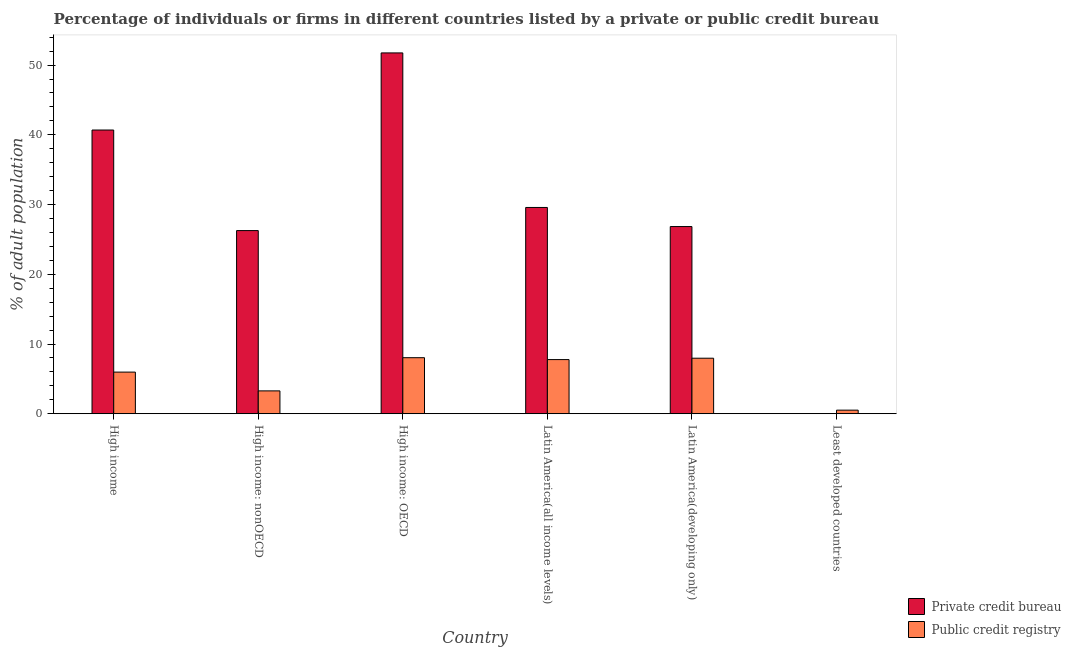How many groups of bars are there?
Provide a short and direct response. 6. Are the number of bars on each tick of the X-axis equal?
Make the answer very short. Yes. How many bars are there on the 5th tick from the right?
Provide a succinct answer. 2. What is the label of the 2nd group of bars from the left?
Provide a succinct answer. High income: nonOECD. In how many cases, is the number of bars for a given country not equal to the number of legend labels?
Your answer should be compact. 0. What is the percentage of firms listed by public credit bureau in Latin America(developing only)?
Your answer should be compact. 7.96. Across all countries, what is the maximum percentage of firms listed by public credit bureau?
Your response must be concise. 8.04. Across all countries, what is the minimum percentage of firms listed by public credit bureau?
Give a very brief answer. 0.51. In which country was the percentage of firms listed by public credit bureau maximum?
Provide a short and direct response. High income: OECD. In which country was the percentage of firms listed by public credit bureau minimum?
Provide a succinct answer. Least developed countries. What is the total percentage of firms listed by private credit bureau in the graph?
Your answer should be compact. 175.12. What is the difference between the percentage of firms listed by public credit bureau in High income and that in High income: OECD?
Your answer should be very brief. -2.06. What is the difference between the percentage of firms listed by private credit bureau in High income: OECD and the percentage of firms listed by public credit bureau in High income?
Your answer should be compact. 45.77. What is the average percentage of firms listed by public credit bureau per country?
Provide a succinct answer. 5.59. What is the difference between the percentage of firms listed by private credit bureau and percentage of firms listed by public credit bureau in High income: nonOECD?
Provide a short and direct response. 22.99. In how many countries, is the percentage of firms listed by private credit bureau greater than 10 %?
Provide a succinct answer. 5. What is the ratio of the percentage of firms listed by private credit bureau in Latin America(all income levels) to that in Latin America(developing only)?
Offer a very short reply. 1.1. Is the percentage of firms listed by public credit bureau in Latin America(developing only) less than that in Least developed countries?
Your answer should be very brief. No. What is the difference between the highest and the second highest percentage of firms listed by private credit bureau?
Give a very brief answer. 11.06. What is the difference between the highest and the lowest percentage of firms listed by public credit bureau?
Provide a short and direct response. 7.52. Is the sum of the percentage of firms listed by private credit bureau in High income: OECD and Latin America(developing only) greater than the maximum percentage of firms listed by public credit bureau across all countries?
Offer a very short reply. Yes. What does the 1st bar from the left in High income: nonOECD represents?
Offer a very short reply. Private credit bureau. What does the 2nd bar from the right in Latin America(developing only) represents?
Your response must be concise. Private credit bureau. Are all the bars in the graph horizontal?
Your answer should be very brief. No. What is the difference between two consecutive major ticks on the Y-axis?
Provide a succinct answer. 10. Does the graph contain any zero values?
Provide a succinct answer. No. How are the legend labels stacked?
Make the answer very short. Vertical. What is the title of the graph?
Offer a terse response. Percentage of individuals or firms in different countries listed by a private or public credit bureau. Does "Manufacturing industries and construction" appear as one of the legend labels in the graph?
Give a very brief answer. No. What is the label or title of the Y-axis?
Provide a short and direct response. % of adult population. What is the % of adult population of Private credit bureau in High income?
Your answer should be compact. 40.69. What is the % of adult population in Public credit registry in High income?
Offer a terse response. 5.97. What is the % of adult population of Private credit bureau in High income: nonOECD?
Your answer should be very brief. 26.27. What is the % of adult population in Public credit registry in High income: nonOECD?
Your response must be concise. 3.28. What is the % of adult population in Private credit bureau in High income: OECD?
Make the answer very short. 51.74. What is the % of adult population in Public credit registry in High income: OECD?
Give a very brief answer. 8.04. What is the % of adult population of Private credit bureau in Latin America(all income levels)?
Ensure brevity in your answer.  29.58. What is the % of adult population in Public credit registry in Latin America(all income levels)?
Provide a succinct answer. 7.77. What is the % of adult population of Private credit bureau in Latin America(developing only)?
Provide a succinct answer. 26.84. What is the % of adult population in Public credit registry in Latin America(developing only)?
Give a very brief answer. 7.96. What is the % of adult population in Private credit bureau in Least developed countries?
Your answer should be compact. 0. What is the % of adult population of Public credit registry in Least developed countries?
Keep it short and to the point. 0.51. Across all countries, what is the maximum % of adult population in Private credit bureau?
Keep it short and to the point. 51.74. Across all countries, what is the maximum % of adult population of Public credit registry?
Ensure brevity in your answer.  8.04. Across all countries, what is the minimum % of adult population in Private credit bureau?
Your answer should be very brief. 0. Across all countries, what is the minimum % of adult population of Public credit registry?
Provide a succinct answer. 0.51. What is the total % of adult population in Private credit bureau in the graph?
Your response must be concise. 175.12. What is the total % of adult population in Public credit registry in the graph?
Your response must be concise. 33.53. What is the difference between the % of adult population in Private credit bureau in High income and that in High income: nonOECD?
Your answer should be very brief. 14.42. What is the difference between the % of adult population in Public credit registry in High income and that in High income: nonOECD?
Provide a short and direct response. 2.69. What is the difference between the % of adult population in Private credit bureau in High income and that in High income: OECD?
Your answer should be very brief. -11.06. What is the difference between the % of adult population of Public credit registry in High income and that in High income: OECD?
Offer a terse response. -2.06. What is the difference between the % of adult population of Private credit bureau in High income and that in Latin America(all income levels)?
Your answer should be compact. 11.11. What is the difference between the % of adult population in Public credit registry in High income and that in Latin America(all income levels)?
Provide a short and direct response. -1.79. What is the difference between the % of adult population of Private credit bureau in High income and that in Latin America(developing only)?
Offer a terse response. 13.84. What is the difference between the % of adult population of Public credit registry in High income and that in Latin America(developing only)?
Give a very brief answer. -1.99. What is the difference between the % of adult population of Private credit bureau in High income and that in Least developed countries?
Your answer should be very brief. 40.68. What is the difference between the % of adult population of Public credit registry in High income and that in Least developed countries?
Provide a succinct answer. 5.46. What is the difference between the % of adult population in Private credit bureau in High income: nonOECD and that in High income: OECD?
Your answer should be very brief. -25.48. What is the difference between the % of adult population of Public credit registry in High income: nonOECD and that in High income: OECD?
Offer a very short reply. -4.76. What is the difference between the % of adult population in Private credit bureau in High income: nonOECD and that in Latin America(all income levels)?
Your response must be concise. -3.31. What is the difference between the % of adult population of Public credit registry in High income: nonOECD and that in Latin America(all income levels)?
Your answer should be compact. -4.49. What is the difference between the % of adult population of Private credit bureau in High income: nonOECD and that in Latin America(developing only)?
Keep it short and to the point. -0.58. What is the difference between the % of adult population of Public credit registry in High income: nonOECD and that in Latin America(developing only)?
Your answer should be compact. -4.68. What is the difference between the % of adult population of Private credit bureau in High income: nonOECD and that in Least developed countries?
Provide a succinct answer. 26.26. What is the difference between the % of adult population of Public credit registry in High income: nonOECD and that in Least developed countries?
Make the answer very short. 2.76. What is the difference between the % of adult population in Private credit bureau in High income: OECD and that in Latin America(all income levels)?
Ensure brevity in your answer.  22.16. What is the difference between the % of adult population of Public credit registry in High income: OECD and that in Latin America(all income levels)?
Keep it short and to the point. 0.27. What is the difference between the % of adult population of Private credit bureau in High income: OECD and that in Latin America(developing only)?
Give a very brief answer. 24.9. What is the difference between the % of adult population in Public credit registry in High income: OECD and that in Latin America(developing only)?
Provide a short and direct response. 0.07. What is the difference between the % of adult population in Private credit bureau in High income: OECD and that in Least developed countries?
Ensure brevity in your answer.  51.74. What is the difference between the % of adult population of Public credit registry in High income: OECD and that in Least developed countries?
Make the answer very short. 7.52. What is the difference between the % of adult population of Private credit bureau in Latin America(all income levels) and that in Latin America(developing only)?
Your answer should be very brief. 2.74. What is the difference between the % of adult population of Public credit registry in Latin America(all income levels) and that in Latin America(developing only)?
Make the answer very short. -0.2. What is the difference between the % of adult population of Private credit bureau in Latin America(all income levels) and that in Least developed countries?
Make the answer very short. 29.58. What is the difference between the % of adult population in Public credit registry in Latin America(all income levels) and that in Least developed countries?
Keep it short and to the point. 7.25. What is the difference between the % of adult population in Private credit bureau in Latin America(developing only) and that in Least developed countries?
Give a very brief answer. 26.84. What is the difference between the % of adult population of Public credit registry in Latin America(developing only) and that in Least developed countries?
Provide a short and direct response. 7.45. What is the difference between the % of adult population of Private credit bureau in High income and the % of adult population of Public credit registry in High income: nonOECD?
Your answer should be very brief. 37.41. What is the difference between the % of adult population in Private credit bureau in High income and the % of adult population in Public credit registry in High income: OECD?
Ensure brevity in your answer.  32.65. What is the difference between the % of adult population of Private credit bureau in High income and the % of adult population of Public credit registry in Latin America(all income levels)?
Provide a succinct answer. 32.92. What is the difference between the % of adult population in Private credit bureau in High income and the % of adult population in Public credit registry in Latin America(developing only)?
Your answer should be compact. 32.72. What is the difference between the % of adult population of Private credit bureau in High income and the % of adult population of Public credit registry in Least developed countries?
Provide a succinct answer. 40.17. What is the difference between the % of adult population in Private credit bureau in High income: nonOECD and the % of adult population in Public credit registry in High income: OECD?
Your answer should be very brief. 18.23. What is the difference between the % of adult population of Private credit bureau in High income: nonOECD and the % of adult population of Public credit registry in Latin America(all income levels)?
Ensure brevity in your answer.  18.5. What is the difference between the % of adult population of Private credit bureau in High income: nonOECD and the % of adult population of Public credit registry in Latin America(developing only)?
Make the answer very short. 18.3. What is the difference between the % of adult population of Private credit bureau in High income: nonOECD and the % of adult population of Public credit registry in Least developed countries?
Your answer should be compact. 25.75. What is the difference between the % of adult population in Private credit bureau in High income: OECD and the % of adult population in Public credit registry in Latin America(all income levels)?
Ensure brevity in your answer.  43.98. What is the difference between the % of adult population in Private credit bureau in High income: OECD and the % of adult population in Public credit registry in Latin America(developing only)?
Provide a succinct answer. 43.78. What is the difference between the % of adult population of Private credit bureau in High income: OECD and the % of adult population of Public credit registry in Least developed countries?
Your response must be concise. 51.23. What is the difference between the % of adult population of Private credit bureau in Latin America(all income levels) and the % of adult population of Public credit registry in Latin America(developing only)?
Make the answer very short. 21.62. What is the difference between the % of adult population in Private credit bureau in Latin America(all income levels) and the % of adult population in Public credit registry in Least developed countries?
Give a very brief answer. 29.07. What is the difference between the % of adult population of Private credit bureau in Latin America(developing only) and the % of adult population of Public credit registry in Least developed countries?
Ensure brevity in your answer.  26.33. What is the average % of adult population in Private credit bureau per country?
Offer a terse response. 29.19. What is the average % of adult population of Public credit registry per country?
Offer a very short reply. 5.59. What is the difference between the % of adult population of Private credit bureau and % of adult population of Public credit registry in High income?
Your answer should be compact. 34.72. What is the difference between the % of adult population in Private credit bureau and % of adult population in Public credit registry in High income: nonOECD?
Provide a short and direct response. 22.99. What is the difference between the % of adult population in Private credit bureau and % of adult population in Public credit registry in High income: OECD?
Ensure brevity in your answer.  43.71. What is the difference between the % of adult population of Private credit bureau and % of adult population of Public credit registry in Latin America(all income levels)?
Provide a short and direct response. 21.81. What is the difference between the % of adult population of Private credit bureau and % of adult population of Public credit registry in Latin America(developing only)?
Ensure brevity in your answer.  18.88. What is the difference between the % of adult population in Private credit bureau and % of adult population in Public credit registry in Least developed countries?
Make the answer very short. -0.51. What is the ratio of the % of adult population in Private credit bureau in High income to that in High income: nonOECD?
Provide a succinct answer. 1.55. What is the ratio of the % of adult population of Public credit registry in High income to that in High income: nonOECD?
Offer a very short reply. 1.82. What is the ratio of the % of adult population of Private credit bureau in High income to that in High income: OECD?
Keep it short and to the point. 0.79. What is the ratio of the % of adult population of Public credit registry in High income to that in High income: OECD?
Ensure brevity in your answer.  0.74. What is the ratio of the % of adult population of Private credit bureau in High income to that in Latin America(all income levels)?
Provide a succinct answer. 1.38. What is the ratio of the % of adult population in Public credit registry in High income to that in Latin America(all income levels)?
Your response must be concise. 0.77. What is the ratio of the % of adult population in Private credit bureau in High income to that in Latin America(developing only)?
Ensure brevity in your answer.  1.52. What is the ratio of the % of adult population in Public credit registry in High income to that in Latin America(developing only)?
Keep it short and to the point. 0.75. What is the ratio of the % of adult population in Private credit bureau in High income to that in Least developed countries?
Your answer should be very brief. 8747.66. What is the ratio of the % of adult population in Public credit registry in High income to that in Least developed countries?
Make the answer very short. 11.62. What is the ratio of the % of adult population in Private credit bureau in High income: nonOECD to that in High income: OECD?
Give a very brief answer. 0.51. What is the ratio of the % of adult population of Public credit registry in High income: nonOECD to that in High income: OECD?
Offer a very short reply. 0.41. What is the ratio of the % of adult population of Private credit bureau in High income: nonOECD to that in Latin America(all income levels)?
Your response must be concise. 0.89. What is the ratio of the % of adult population of Public credit registry in High income: nonOECD to that in Latin America(all income levels)?
Your response must be concise. 0.42. What is the ratio of the % of adult population of Private credit bureau in High income: nonOECD to that in Latin America(developing only)?
Offer a very short reply. 0.98. What is the ratio of the % of adult population of Public credit registry in High income: nonOECD to that in Latin America(developing only)?
Give a very brief answer. 0.41. What is the ratio of the % of adult population in Private credit bureau in High income: nonOECD to that in Least developed countries?
Provide a short and direct response. 5647.02. What is the ratio of the % of adult population of Public credit registry in High income: nonOECD to that in Least developed countries?
Provide a succinct answer. 6.38. What is the ratio of the % of adult population in Private credit bureau in High income: OECD to that in Latin America(all income levels)?
Offer a terse response. 1.75. What is the ratio of the % of adult population in Public credit registry in High income: OECD to that in Latin America(all income levels)?
Provide a succinct answer. 1.03. What is the ratio of the % of adult population in Private credit bureau in High income: OECD to that in Latin America(developing only)?
Make the answer very short. 1.93. What is the ratio of the % of adult population of Public credit registry in High income: OECD to that in Latin America(developing only)?
Offer a very short reply. 1.01. What is the ratio of the % of adult population in Private credit bureau in High income: OECD to that in Least developed countries?
Provide a short and direct response. 1.11e+04. What is the ratio of the % of adult population in Public credit registry in High income: OECD to that in Least developed countries?
Give a very brief answer. 15.64. What is the ratio of the % of adult population of Private credit bureau in Latin America(all income levels) to that in Latin America(developing only)?
Offer a very short reply. 1.1. What is the ratio of the % of adult population in Public credit registry in Latin America(all income levels) to that in Latin America(developing only)?
Your answer should be compact. 0.98. What is the ratio of the % of adult population in Private credit bureau in Latin America(all income levels) to that in Least developed countries?
Provide a succinct answer. 6359.7. What is the ratio of the % of adult population of Public credit registry in Latin America(all income levels) to that in Least developed countries?
Make the answer very short. 15.11. What is the ratio of the % of adult population in Private credit bureau in Latin America(developing only) to that in Least developed countries?
Give a very brief answer. 5771.21. What is the ratio of the % of adult population in Public credit registry in Latin America(developing only) to that in Least developed countries?
Offer a very short reply. 15.49. What is the difference between the highest and the second highest % of adult population of Private credit bureau?
Your answer should be very brief. 11.06. What is the difference between the highest and the second highest % of adult population in Public credit registry?
Your answer should be compact. 0.07. What is the difference between the highest and the lowest % of adult population in Private credit bureau?
Provide a short and direct response. 51.74. What is the difference between the highest and the lowest % of adult population of Public credit registry?
Your answer should be very brief. 7.52. 